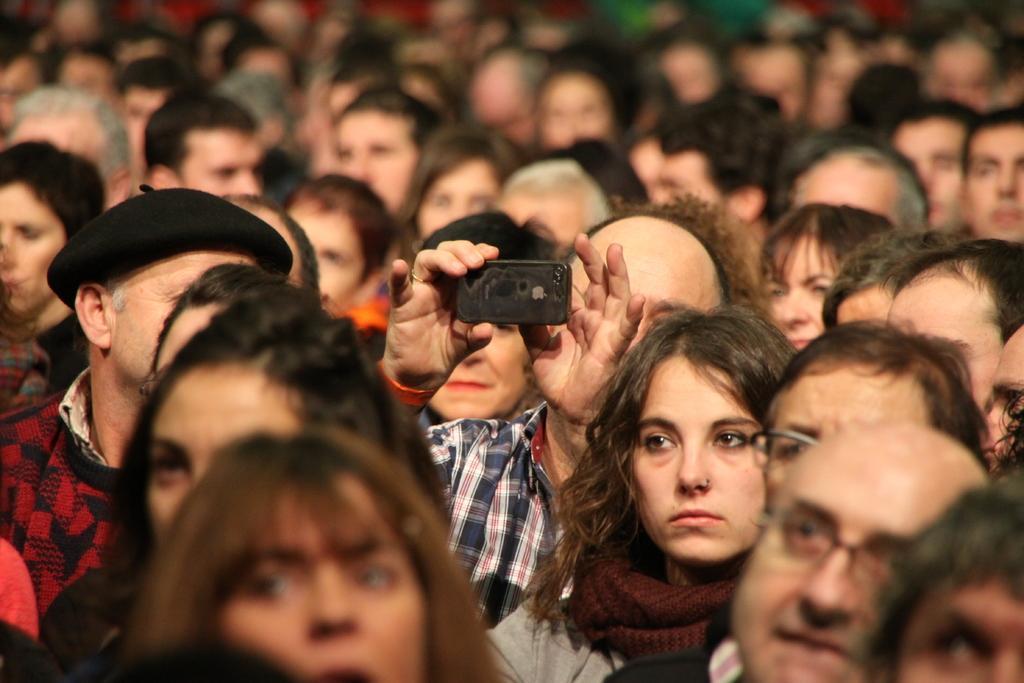Could you give a brief overview of what you see in this image? In this image there are many people. The man in the center is holding a mobile phone in his hand. Beside him there is another man and he is wearing a hat. 